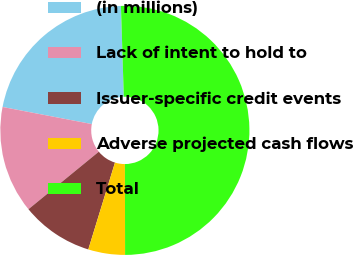<chart> <loc_0><loc_0><loc_500><loc_500><pie_chart><fcel>(in millions)<fcel>Lack of intent to hold to<fcel>Issuer-specific credit events<fcel>Adverse projected cash flows<fcel>Total<nl><fcel>21.49%<fcel>13.92%<fcel>9.35%<fcel>4.77%<fcel>50.48%<nl></chart> 